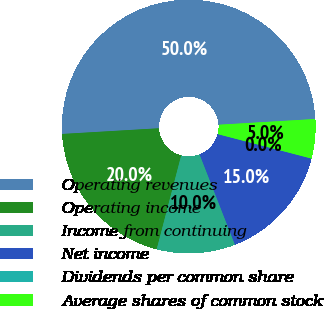<chart> <loc_0><loc_0><loc_500><loc_500><pie_chart><fcel>Operating revenues<fcel>Operating income<fcel>Income from continuing<fcel>Net income<fcel>Dividends per common share<fcel>Average shares of common stock<nl><fcel>49.99%<fcel>20.0%<fcel>10.0%<fcel>15.0%<fcel>0.01%<fcel>5.0%<nl></chart> 